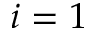Convert formula to latex. <formula><loc_0><loc_0><loc_500><loc_500>i = 1</formula> 